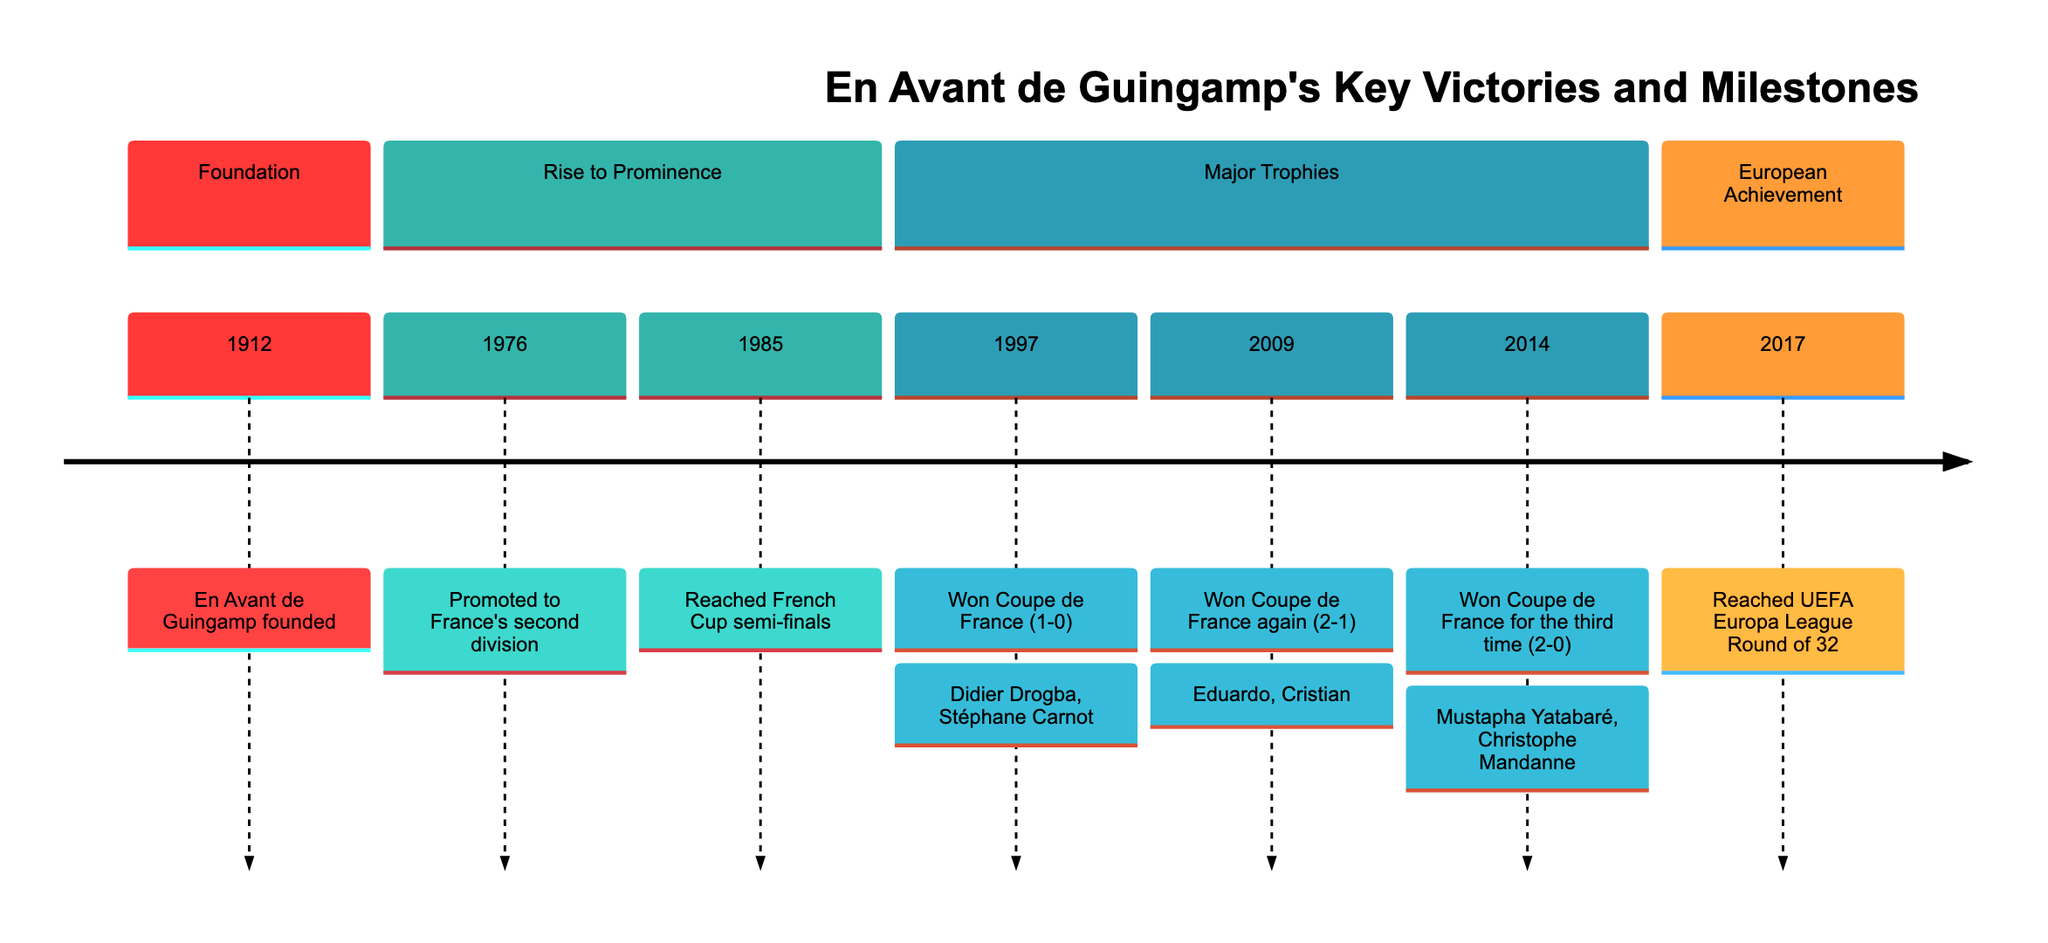What year was En Avant de Guingamp founded? The diagram shows a section labeled "Foundation" with the year 1912 next to the statement indicating the founding of En Avant de Guingamp.
Answer: 1912 What was the score when En Avant de Guingamp won the Coupe de France in 2009? The diagram lists the year 2009 under the "Major Trophies" section, detailing that En Avant de Guingamp won the Coupe de France with a score of 2-1.
Answer: 2-1 Which players were involved in the 1997 Coupe de France victory? Under the "Major Trophies" section, the 1997 Coupe de France winning entry mentions Didier Drogba and Stéphane Carnot.
Answer: Didier Drogba, Stéphane Carnot How many times did En Avant de Guingamp win the Coupe de France as shown in the diagram? The diagram indicates three instances of Coupe de France victories listed under "Major Trophies" sections: 1997, 2009, and 2014, totaling three times.
Answer: 3 Which milestone occurred in 2014? The diagram clearly states that in 2014, En Avant de Guingamp won the Coupe de France for the third time, making it a significant milestone.
Answer: Won Coupe de France What major division was En Avant de Guingamp promoted to in 1976? The diagram indicates that, in 1976, En Avant de Guingamp was promoted to France's second division, which is explicitly stated in the "Rise to Prominence" section.
Answer: France's second division What is the earliest key victory mentioned in the diagram? By reviewing the timeline from the diagram, the earliest key victory mentioned is the winning of the Coupe de France in 1997, as it's the first trophy after the club's foundation and rise in the timeline.
Answer: 1997 How many total key milestones are listed in the diagram? The timeline lists a total of seven key milestones: Foundation (1), Rise to Prominence (2), Major Trophies (3), and European Achievement (1), leading to a total of seven milestones.
Answer: 7 